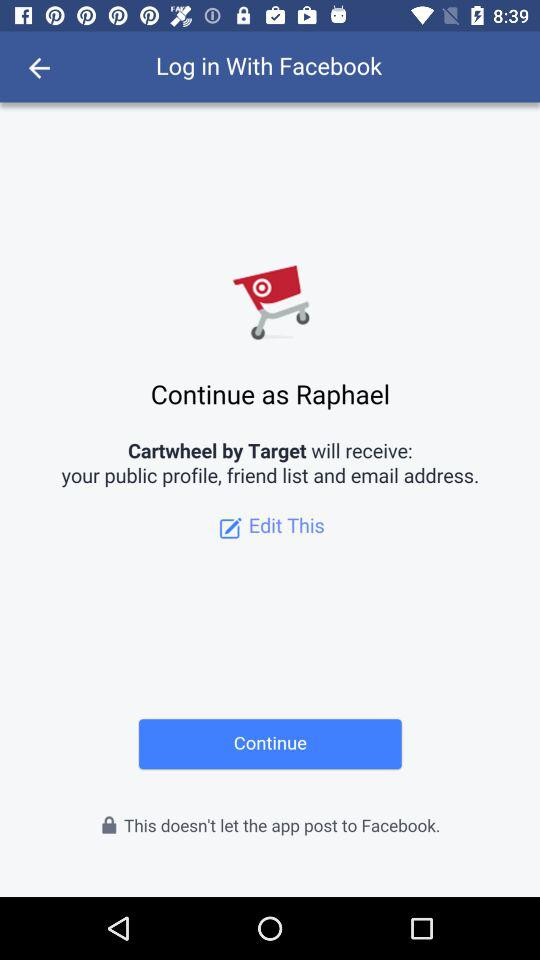How can we log in? You can log in with "Facebook". 